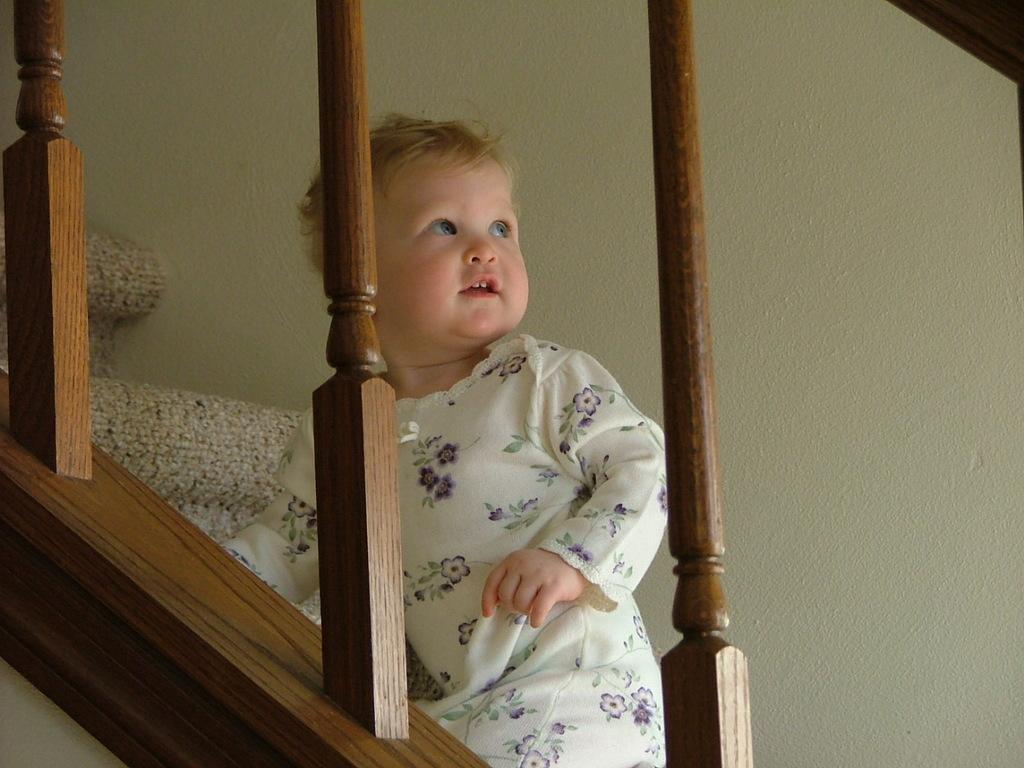What is the main subject of the image? There is a baby in the image. Where is the baby located? The baby is on a staircase. What type of material can be seen in the image? There are wooden poles visible in the image. What can be seen in the background of the image? There is a wall visible in the background of the image. How many roses are present in the image? There are no roses present in the image. What type of game is the baby playing on the staircase? The image does not show the baby playing a game; it simply depicts the baby on a staircase. 